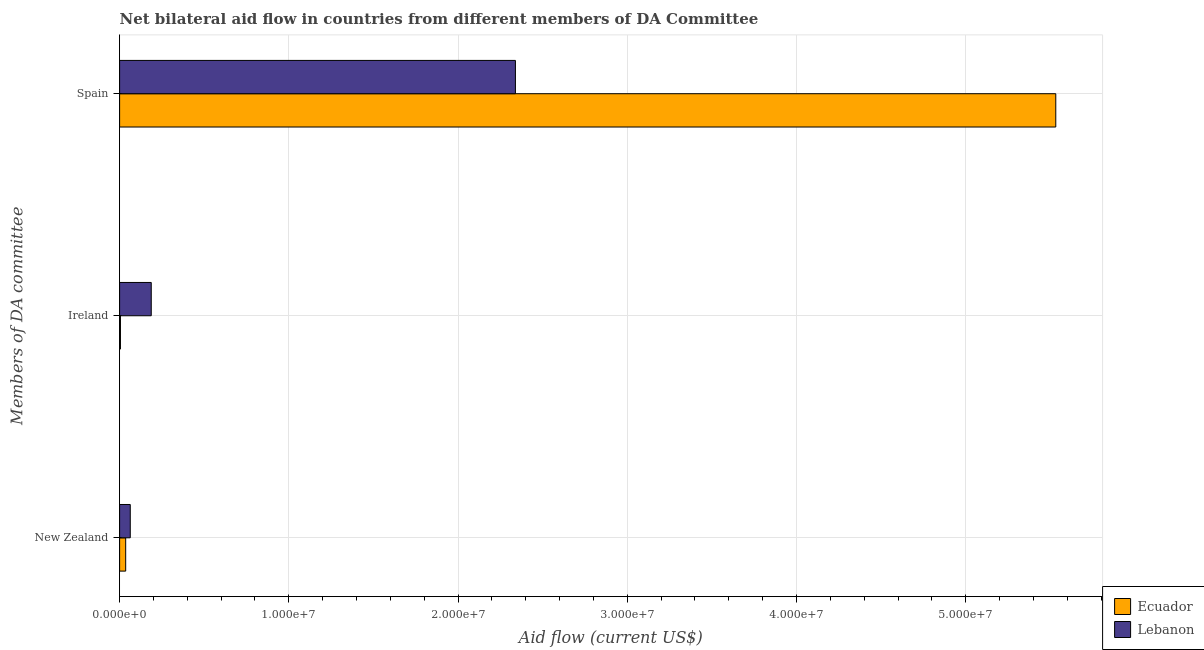How many different coloured bars are there?
Keep it short and to the point. 2. Are the number of bars per tick equal to the number of legend labels?
Provide a succinct answer. Yes. Are the number of bars on each tick of the Y-axis equal?
Make the answer very short. Yes. How many bars are there on the 2nd tick from the bottom?
Provide a succinct answer. 2. What is the label of the 2nd group of bars from the top?
Provide a succinct answer. Ireland. What is the amount of aid provided by spain in Ecuador?
Offer a terse response. 5.53e+07. Across all countries, what is the maximum amount of aid provided by spain?
Provide a succinct answer. 5.53e+07. Across all countries, what is the minimum amount of aid provided by ireland?
Offer a terse response. 5.00e+04. In which country was the amount of aid provided by new zealand maximum?
Your answer should be compact. Lebanon. In which country was the amount of aid provided by ireland minimum?
Provide a succinct answer. Ecuador. What is the total amount of aid provided by spain in the graph?
Your response must be concise. 7.87e+07. What is the difference between the amount of aid provided by ireland in Ecuador and that in Lebanon?
Ensure brevity in your answer.  -1.82e+06. What is the difference between the amount of aid provided by new zealand in Ecuador and the amount of aid provided by spain in Lebanon?
Make the answer very short. -2.30e+07. What is the average amount of aid provided by spain per country?
Offer a very short reply. 3.94e+07. What is the difference between the amount of aid provided by spain and amount of aid provided by ireland in Lebanon?
Offer a terse response. 2.15e+07. What is the ratio of the amount of aid provided by ireland in Lebanon to that in Ecuador?
Offer a very short reply. 37.4. Is the amount of aid provided by new zealand in Lebanon less than that in Ecuador?
Keep it short and to the point. No. What is the difference between the highest and the second highest amount of aid provided by ireland?
Provide a succinct answer. 1.82e+06. What is the difference between the highest and the lowest amount of aid provided by ireland?
Ensure brevity in your answer.  1.82e+06. In how many countries, is the amount of aid provided by new zealand greater than the average amount of aid provided by new zealand taken over all countries?
Give a very brief answer. 1. What does the 1st bar from the top in New Zealand represents?
Provide a short and direct response. Lebanon. What does the 1st bar from the bottom in Spain represents?
Ensure brevity in your answer.  Ecuador. How many bars are there?
Provide a succinct answer. 6. How many countries are there in the graph?
Your answer should be compact. 2. What is the difference between two consecutive major ticks on the X-axis?
Offer a terse response. 1.00e+07. How many legend labels are there?
Your answer should be very brief. 2. How are the legend labels stacked?
Provide a succinct answer. Vertical. What is the title of the graph?
Offer a terse response. Net bilateral aid flow in countries from different members of DA Committee. What is the label or title of the X-axis?
Offer a terse response. Aid flow (current US$). What is the label or title of the Y-axis?
Give a very brief answer. Members of DA committee. What is the Aid flow (current US$) in Lebanon in New Zealand?
Your answer should be compact. 6.30e+05. What is the Aid flow (current US$) in Lebanon in Ireland?
Offer a terse response. 1.87e+06. What is the Aid flow (current US$) of Ecuador in Spain?
Your answer should be very brief. 5.53e+07. What is the Aid flow (current US$) in Lebanon in Spain?
Your response must be concise. 2.34e+07. Across all Members of DA committee, what is the maximum Aid flow (current US$) in Ecuador?
Your response must be concise. 5.53e+07. Across all Members of DA committee, what is the maximum Aid flow (current US$) of Lebanon?
Give a very brief answer. 2.34e+07. Across all Members of DA committee, what is the minimum Aid flow (current US$) of Lebanon?
Provide a short and direct response. 6.30e+05. What is the total Aid flow (current US$) of Ecuador in the graph?
Offer a terse response. 5.57e+07. What is the total Aid flow (current US$) of Lebanon in the graph?
Your response must be concise. 2.59e+07. What is the difference between the Aid flow (current US$) of Lebanon in New Zealand and that in Ireland?
Provide a succinct answer. -1.24e+06. What is the difference between the Aid flow (current US$) in Ecuador in New Zealand and that in Spain?
Your answer should be very brief. -5.50e+07. What is the difference between the Aid flow (current US$) of Lebanon in New Zealand and that in Spain?
Make the answer very short. -2.28e+07. What is the difference between the Aid flow (current US$) of Ecuador in Ireland and that in Spain?
Provide a succinct answer. -5.53e+07. What is the difference between the Aid flow (current US$) of Lebanon in Ireland and that in Spain?
Keep it short and to the point. -2.15e+07. What is the difference between the Aid flow (current US$) of Ecuador in New Zealand and the Aid flow (current US$) of Lebanon in Ireland?
Ensure brevity in your answer.  -1.51e+06. What is the difference between the Aid flow (current US$) of Ecuador in New Zealand and the Aid flow (current US$) of Lebanon in Spain?
Ensure brevity in your answer.  -2.30e+07. What is the difference between the Aid flow (current US$) of Ecuador in Ireland and the Aid flow (current US$) of Lebanon in Spain?
Your answer should be compact. -2.33e+07. What is the average Aid flow (current US$) of Ecuador per Members of DA committee?
Give a very brief answer. 1.86e+07. What is the average Aid flow (current US$) of Lebanon per Members of DA committee?
Your response must be concise. 8.63e+06. What is the difference between the Aid flow (current US$) in Ecuador and Aid flow (current US$) in Lebanon in New Zealand?
Keep it short and to the point. -2.70e+05. What is the difference between the Aid flow (current US$) in Ecuador and Aid flow (current US$) in Lebanon in Ireland?
Ensure brevity in your answer.  -1.82e+06. What is the difference between the Aid flow (current US$) of Ecuador and Aid flow (current US$) of Lebanon in Spain?
Keep it short and to the point. 3.19e+07. What is the ratio of the Aid flow (current US$) of Lebanon in New Zealand to that in Ireland?
Offer a terse response. 0.34. What is the ratio of the Aid flow (current US$) of Ecuador in New Zealand to that in Spain?
Make the answer very short. 0.01. What is the ratio of the Aid flow (current US$) in Lebanon in New Zealand to that in Spain?
Keep it short and to the point. 0.03. What is the ratio of the Aid flow (current US$) in Ecuador in Ireland to that in Spain?
Provide a succinct answer. 0. What is the ratio of the Aid flow (current US$) in Lebanon in Ireland to that in Spain?
Give a very brief answer. 0.08. What is the difference between the highest and the second highest Aid flow (current US$) of Ecuador?
Offer a terse response. 5.50e+07. What is the difference between the highest and the second highest Aid flow (current US$) in Lebanon?
Your response must be concise. 2.15e+07. What is the difference between the highest and the lowest Aid flow (current US$) of Ecuador?
Your answer should be compact. 5.53e+07. What is the difference between the highest and the lowest Aid flow (current US$) of Lebanon?
Offer a terse response. 2.28e+07. 